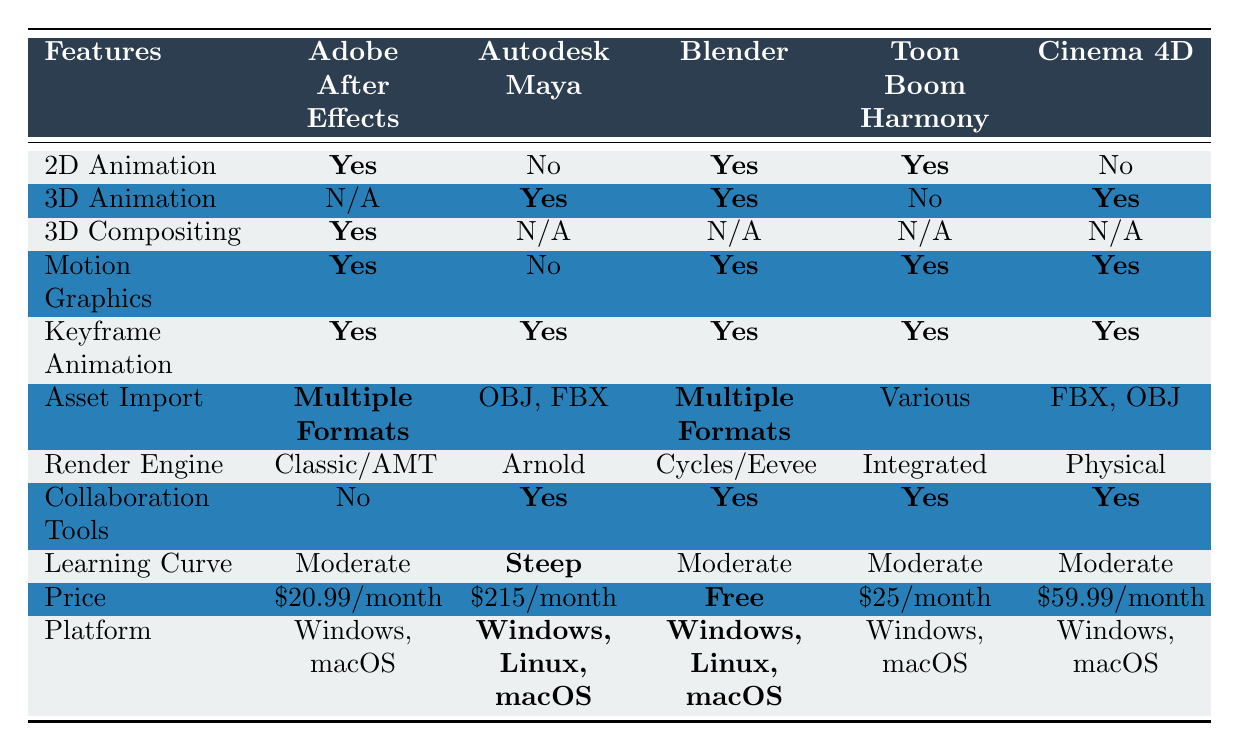What software offers 2D animation capabilities? The table shows that Adobe After Effects, Blender, and Toon Boom Harmony all indicate "Yes" for 2D Animation.
Answer: Adobe After Effects, Blender, Toon Boom Harmony Which software has the highest price? By examining the "Price" row, Autodesk Maya has the highest price listed at $215/month.
Answer: Autodesk Maya Is there any software that allows 3D animation and is free? The table shows that Blender allows for 3D Animation and has a price listed as "Free."
Answer: Yes Which software provides collaboration tools? According to the table, Autodesk Maya, Blender, Toon Boom Harmony, and Cinema 4D all have "Yes" under Collaboration Tools.
Answer: Autodesk Maya, Blender, Toon Boom Harmony, Cinema 4D What is the average price of the software listed? The prices for the software (in numeric form) are 20.99, 215, 0, 25, and 59.99. Summing these values gives 320.98, and dividing by 5 (the number of software options) results in an average price of 64.196.
Answer: \$64.20 Which software can do motion graphics and has a steep learning curve? From the table, Autodesk Maya has "No" for Motion Graphics and a "Steep" learning curve. Therefore, it does not meet the criteria.
Answer: None Is there software available on all platforms listed? By checking the "Platform" column, all software except Autodesk Maya runs on "Windows, macOS." However, Maya also supports Linux, so none is available on every platform listed.
Answer: No What is the unique feature of Adobe After Effects that is not present in other software? The table indicates that Adobe After Effects has 3D Compositing as a feature, which none of the other software options have.
Answer: 3D Compositing How many software options support keyframe animation? All software listed (Adobe After Effects, Autodesk Maya, Blender, Toon Boom Harmony, Cinema 4D) support Keyframe Animation, as they all have "Yes" under this feature.
Answer: 5 Which software is the best for both 2D and 3D animation? According to the table, Blender is the only software that offers both 2D and 3D animation capabilities.
Answer: Blender 